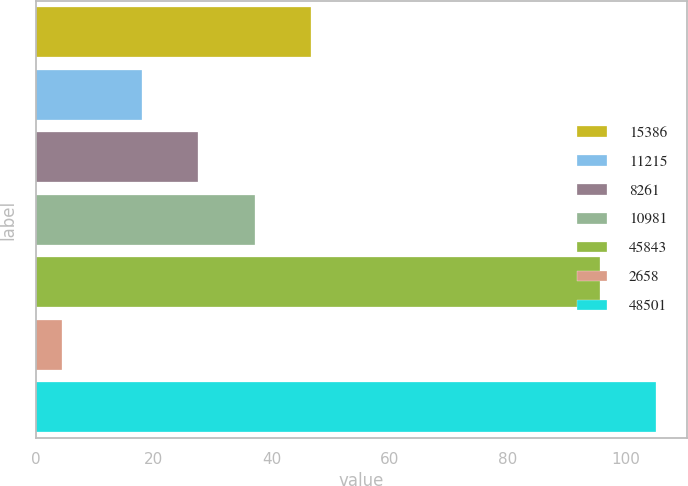Convert chart to OTSL. <chart><loc_0><loc_0><loc_500><loc_500><bar_chart><fcel>15386<fcel>11215<fcel>8261<fcel>10981<fcel>45843<fcel>2658<fcel>48501<nl><fcel>46.68<fcel>18<fcel>27.56<fcel>37.12<fcel>95.6<fcel>4.4<fcel>105.16<nl></chart> 